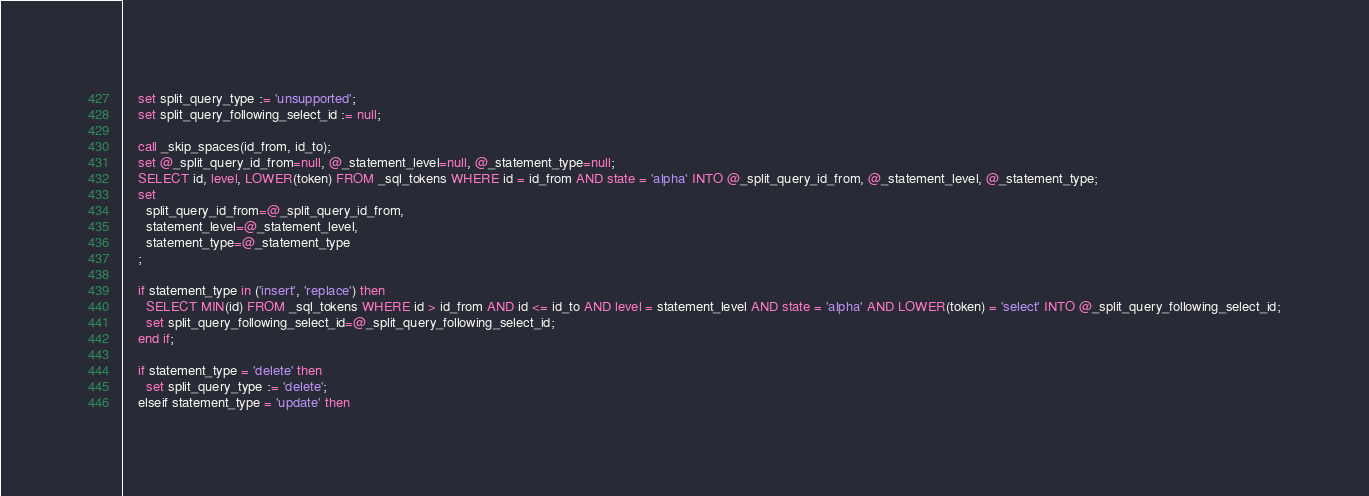Convert code to text. <code><loc_0><loc_0><loc_500><loc_500><_SQL_>
    set split_query_type := 'unsupported';
    set split_query_following_select_id := null;

    call _skip_spaces(id_from, id_to);
    set @_split_query_id_from=null, @_statement_level=null, @_statement_type=null;
    SELECT id, level, LOWER(token) FROM _sql_tokens WHERE id = id_from AND state = 'alpha' INTO @_split_query_id_from, @_statement_level, @_statement_type;
    set
      split_query_id_from=@_split_query_id_from,
      statement_level=@_statement_level,
      statement_type=@_statement_type
    ;

	if statement_type in ('insert', 'replace') then
      SELECT MIN(id) FROM _sql_tokens WHERE id > id_from AND id <= id_to AND level = statement_level AND state = 'alpha' AND LOWER(token) = 'select' INTO @_split_query_following_select_id;
      set split_query_following_select_id=@_split_query_following_select_id;
    end if;

    if statement_type = 'delete' then
      set split_query_type := 'delete';
    elseif statement_type = 'update' then</code> 